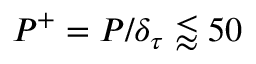Convert formula to latex. <formula><loc_0><loc_0><loc_500><loc_500>P ^ { + } = P / \delta _ { \tau } \lessapprox 5 0</formula> 